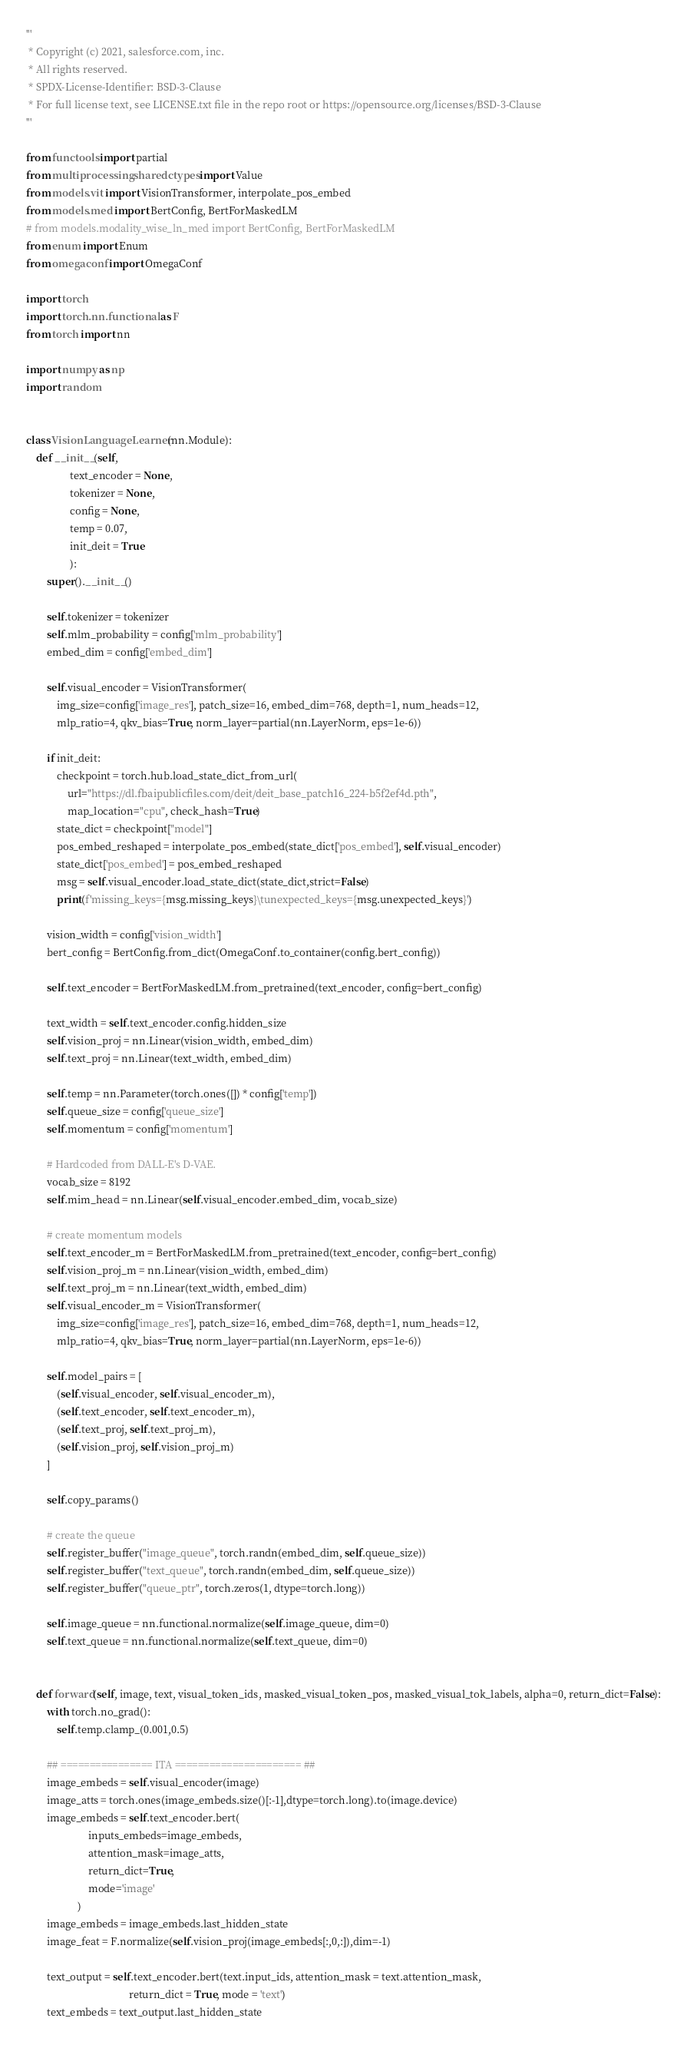Convert code to text. <code><loc_0><loc_0><loc_500><loc_500><_Python_>'''
 * Copyright (c) 2021, salesforce.com, inc.
 * All rights reserved.
 * SPDX-License-Identifier: BSD-3-Clause
 * For full license text, see LICENSE.txt file in the repo root or https://opensource.org/licenses/BSD-3-Clause
'''

from functools import partial
from multiprocessing.sharedctypes import Value
from models.vit import VisionTransformer, interpolate_pos_embed
from models.med import BertConfig, BertForMaskedLM
# from models.modality_wise_ln_med import BertConfig, BertForMaskedLM
from enum import Enum
from omegaconf import OmegaConf

import torch
import torch.nn.functional as F
from torch import nn

import numpy as np
import random


class VisionLanguageLearner(nn.Module):
    def __init__(self,                 
                 text_encoder = None,
                 tokenizer = None,
                 config = None,    
                 temp = 0.07,
                 init_deit = True
                 ):
        super().__init__()
        
        self.tokenizer = tokenizer 
        self.mlm_probability = config['mlm_probability']
        embed_dim = config['embed_dim']
     
        self.visual_encoder = VisionTransformer(
            img_size=config['image_res'], patch_size=16, embed_dim=768, depth=1, num_heads=12, 
            mlp_ratio=4, qkv_bias=True, norm_layer=partial(nn.LayerNorm, eps=1e-6))   
        
        if init_deit:
            checkpoint = torch.hub.load_state_dict_from_url(
                url="https://dl.fbaipublicfiles.com/deit/deit_base_patch16_224-b5f2ef4d.pth",
                map_location="cpu", check_hash=True)
            state_dict = checkpoint["model"]
            pos_embed_reshaped = interpolate_pos_embed(state_dict['pos_embed'], self.visual_encoder)
            state_dict['pos_embed'] = pos_embed_reshaped
            msg = self.visual_encoder.load_state_dict(state_dict,strict=False)
            print(f'missing_keys={msg.missing_keys}\tunexpected_keys={msg.unexpected_keys}')         
            
        vision_width = config['vision_width']       
        bert_config = BertConfig.from_dict(OmegaConf.to_container(config.bert_config))
        
        self.text_encoder = BertForMaskedLM.from_pretrained(text_encoder, config=bert_config)      

        text_width = self.text_encoder.config.hidden_size
        self.vision_proj = nn.Linear(vision_width, embed_dim)
        self.text_proj = nn.Linear(text_width, embed_dim)         

        self.temp = nn.Parameter(torch.ones([]) * config['temp'])   
        self.queue_size = config['queue_size']
        self.momentum = config['momentum']  

        # Hardcoded from DALL-E's D-VAE.
        vocab_size = 8192
        self.mim_head = nn.Linear(self.visual_encoder.embed_dim, vocab_size)

        # create momentum models
        self.text_encoder_m = BertForMaskedLM.from_pretrained(text_encoder, config=bert_config)       
        self.vision_proj_m = nn.Linear(vision_width, embed_dim)
        self.text_proj_m = nn.Linear(text_width, embed_dim)    
        self.visual_encoder_m = VisionTransformer(
            img_size=config['image_res'], patch_size=16, embed_dim=768, depth=1, num_heads=12, 
            mlp_ratio=4, qkv_bias=True, norm_layer=partial(nn.LayerNorm, eps=1e-6))   
        
        self.model_pairs = [
            (self.visual_encoder, self.visual_encoder_m),
            (self.text_encoder, self.text_encoder_m),
            (self.text_proj, self.text_proj_m),
            (self.vision_proj, self.vision_proj_m)
        ]
        
        self.copy_params()

        # create the queue
        self.register_buffer("image_queue", torch.randn(embed_dim, self.queue_size))
        self.register_buffer("text_queue", torch.randn(embed_dim, self.queue_size))
        self.register_buffer("queue_ptr", torch.zeros(1, dtype=torch.long))  
                             
        self.image_queue = nn.functional.normalize(self.image_queue, dim=0)
        self.text_queue = nn.functional.normalize(self.text_queue, dim=0)


    def forward(self, image, text, visual_token_ids, masked_visual_token_pos, masked_visual_tok_labels, alpha=0, return_dict=False):
        with torch.no_grad():
            self.temp.clamp_(0.001,0.5)

        ## ================ ITA ====================== ##
        image_embeds = self.visual_encoder(image) 
        image_atts = torch.ones(image_embeds.size()[:-1],dtype=torch.long).to(image.device)
        image_embeds = self.text_encoder.bert(
                        inputs_embeds=image_embeds, 
                        attention_mask=image_atts,
                        return_dict=True,
                        mode='image'
                    )
        image_embeds = image_embeds.last_hidden_state
        image_feat = F.normalize(self.vision_proj(image_embeds[:,0,:]),dim=-1)  

        text_output = self.text_encoder.bert(text.input_ids, attention_mask = text.attention_mask,                      
                                        return_dict = True, mode = 'text')            
        text_embeds = text_output.last_hidden_state</code> 